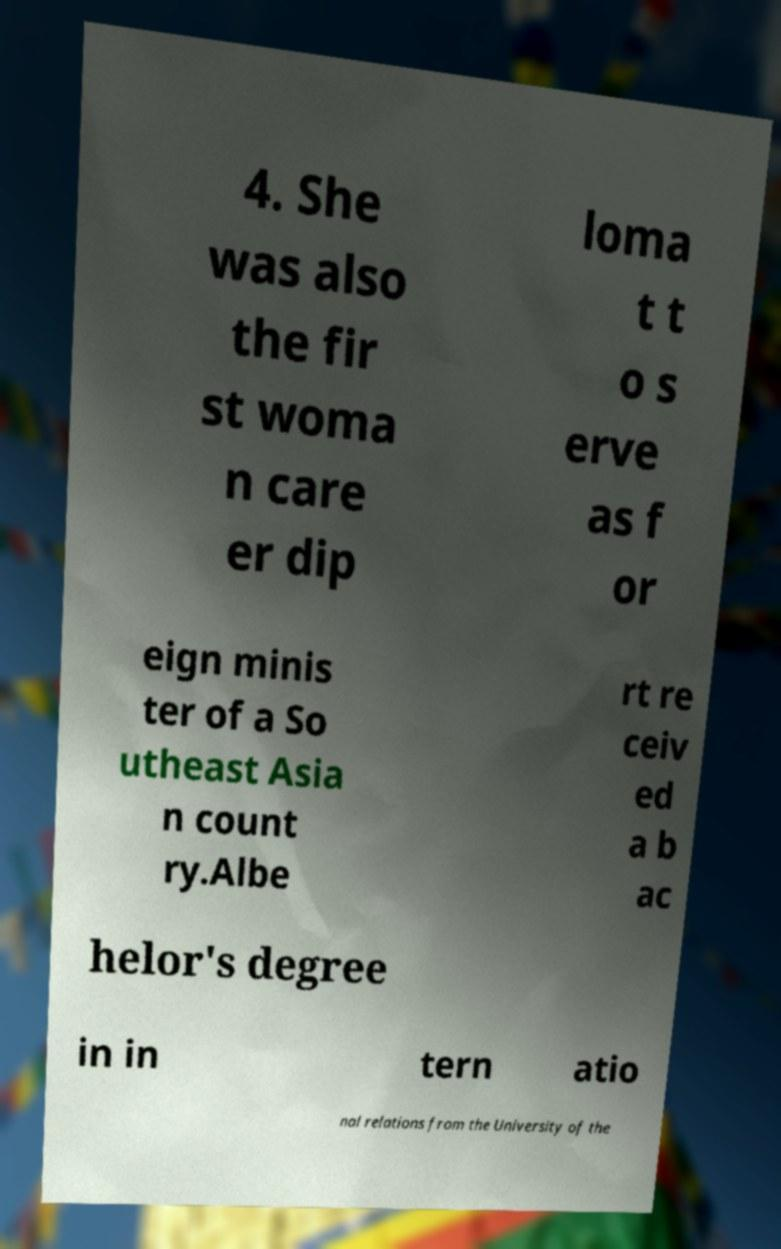Please read and relay the text visible in this image. What does it say? 4. She was also the fir st woma n care er dip loma t t o s erve as f or eign minis ter of a So utheast Asia n count ry.Albe rt re ceiv ed a b ac helor's degree in in tern atio nal relations from the University of the 